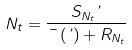Convert formula to latex. <formula><loc_0><loc_0><loc_500><loc_500>N _ { t } = \frac { S _ { N _ { t } } \varphi } { \mu \left ( \varphi \right ) + R _ { N _ { t } } }</formula> 